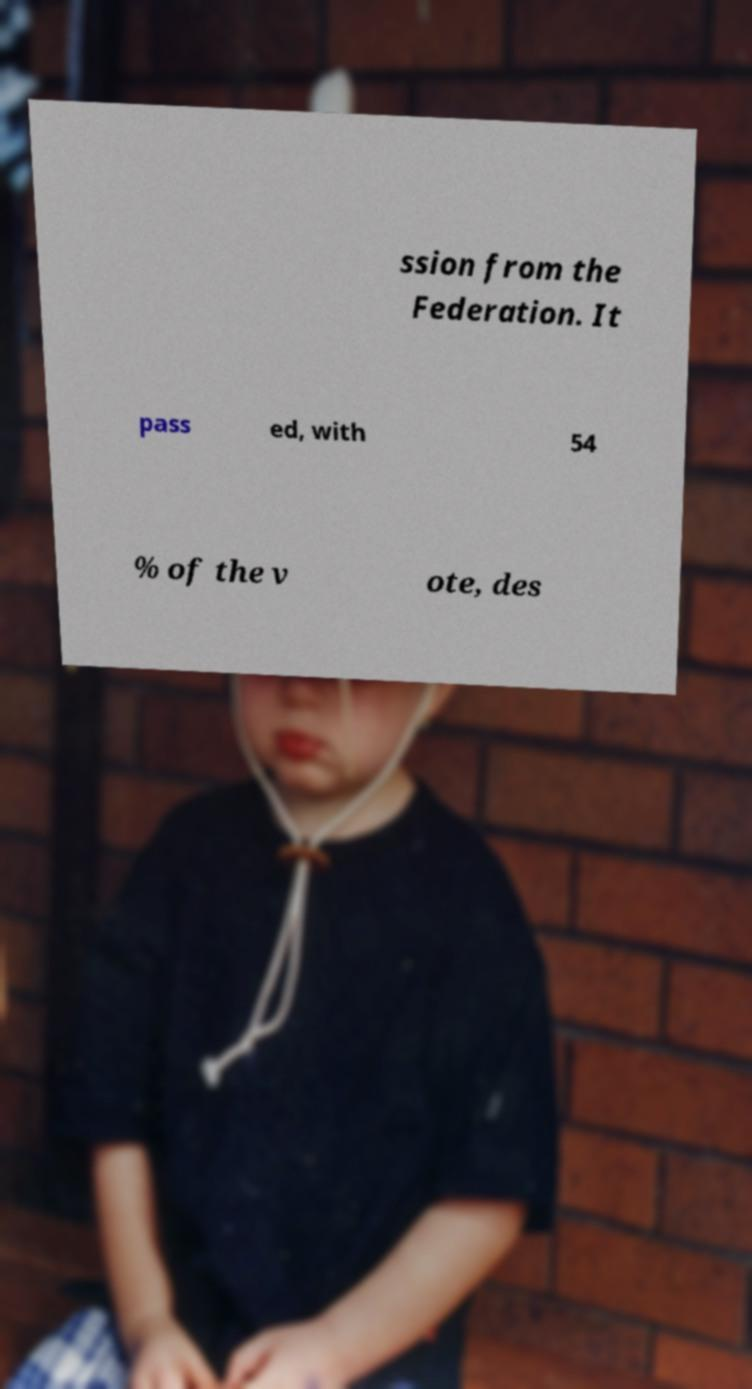I need the written content from this picture converted into text. Can you do that? ssion from the Federation. It pass ed, with 54 % of the v ote, des 